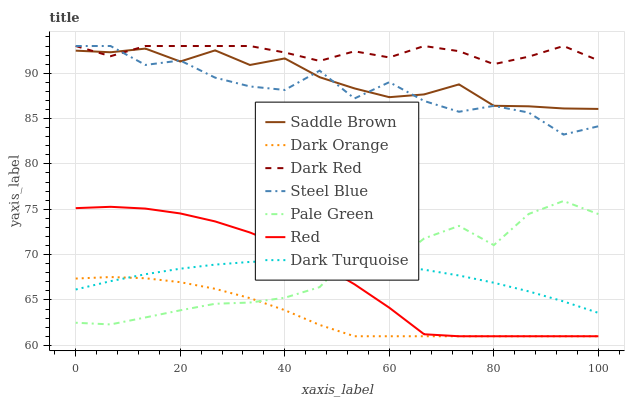Does Dark Orange have the minimum area under the curve?
Answer yes or no. Yes. Does Dark Red have the maximum area under the curve?
Answer yes or no. Yes. Does Steel Blue have the minimum area under the curve?
Answer yes or no. No. Does Steel Blue have the maximum area under the curve?
Answer yes or no. No. Is Dark Turquoise the smoothest?
Answer yes or no. Yes. Is Steel Blue the roughest?
Answer yes or no. Yes. Is Dark Red the smoothest?
Answer yes or no. No. Is Dark Red the roughest?
Answer yes or no. No. Does Dark Orange have the lowest value?
Answer yes or no. Yes. Does Steel Blue have the lowest value?
Answer yes or no. No. Does Steel Blue have the highest value?
Answer yes or no. Yes. Does Pale Green have the highest value?
Answer yes or no. No. Is Pale Green less than Dark Red?
Answer yes or no. Yes. Is Saddle Brown greater than Red?
Answer yes or no. Yes. Does Pale Green intersect Red?
Answer yes or no. Yes. Is Pale Green less than Red?
Answer yes or no. No. Is Pale Green greater than Red?
Answer yes or no. No. Does Pale Green intersect Dark Red?
Answer yes or no. No. 